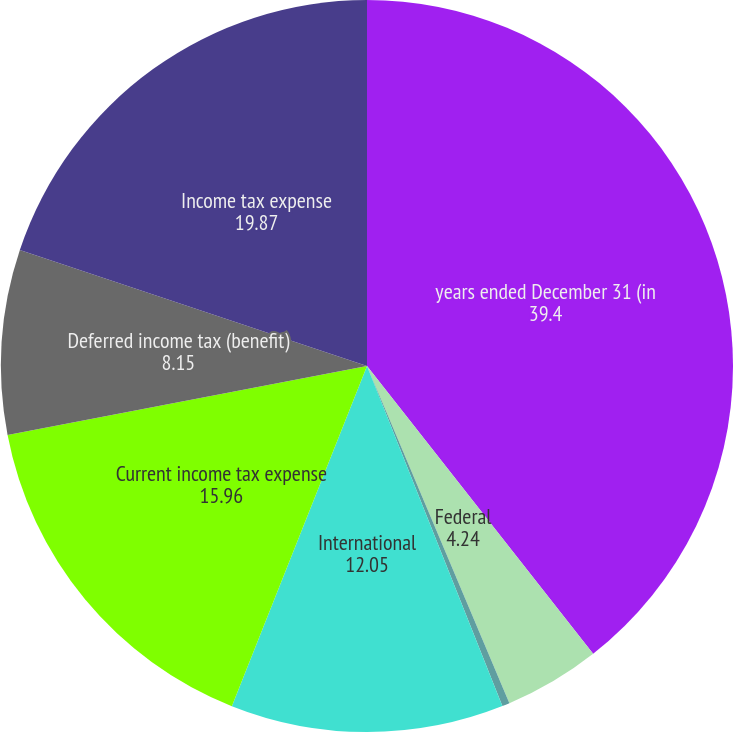Convert chart to OTSL. <chart><loc_0><loc_0><loc_500><loc_500><pie_chart><fcel>years ended December 31 (in<fcel>Federal<fcel>State and local<fcel>International<fcel>Current income tax expense<fcel>Deferred income tax (benefit)<fcel>Income tax expense<nl><fcel>39.4%<fcel>4.24%<fcel>0.33%<fcel>12.05%<fcel>15.96%<fcel>8.15%<fcel>19.87%<nl></chart> 